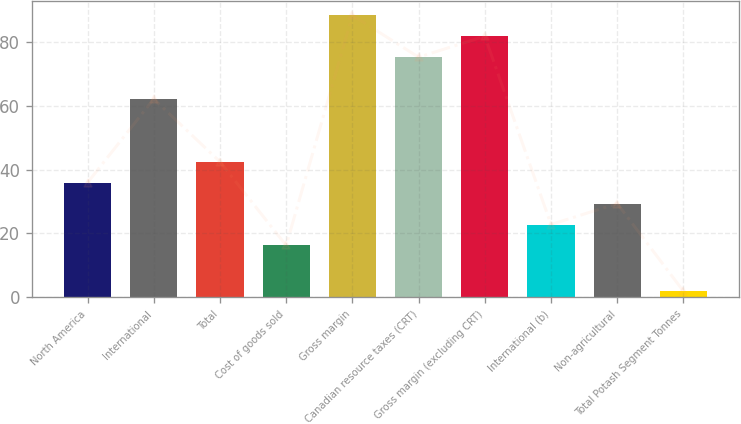Convert chart. <chart><loc_0><loc_0><loc_500><loc_500><bar_chart><fcel>North America<fcel>International<fcel>Total<fcel>Cost of goods sold<fcel>Gross margin<fcel>Canadian resource taxes (CRT)<fcel>Gross margin (excluding CRT)<fcel>International (b)<fcel>Non-agricultural<fcel>Total Potash Segment Tonnes<nl><fcel>35.9<fcel>62.1<fcel>42.45<fcel>16.25<fcel>88.3<fcel>75.2<fcel>81.75<fcel>22.8<fcel>29.35<fcel>1.9<nl></chart> 